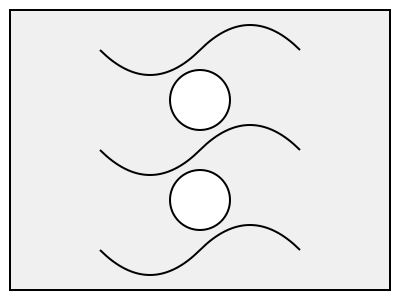Which of the three wavy lines in the image would best complete the pattern if placed between the two circles? To solve this puzzle, let's follow these steps:

1. Observe the overall pattern: There are three wavy lines and two circles in the image.

2. Analyze the positioning of the elements:
   - The circles are placed vertically in the center of the image.
   - The wavy lines are horizontally distributed across the image.

3. Look at the spacing between elements:
   - The circles are evenly spaced vertically.
   - There's a gap between the circles where a wavy line could fit.

4. Compare the wavy lines:
   - Top line: positioned above both circles
   - Middle line: aligns with the space between the circles
   - Bottom line: positioned below both circles

5. Consider the pattern completion:
   - To maintain symmetry and consistent spacing, the line that fits between the circles would complete the pattern best.

6. Conclude: The middle wavy line would best fit between the two circles to complete the pattern.

This exercise helps in recognizing spatial relationships and pattern completion, which are important aspects of spatial intelligence and cognitive rehabilitation after a brain injury.
Answer: Middle wavy line 